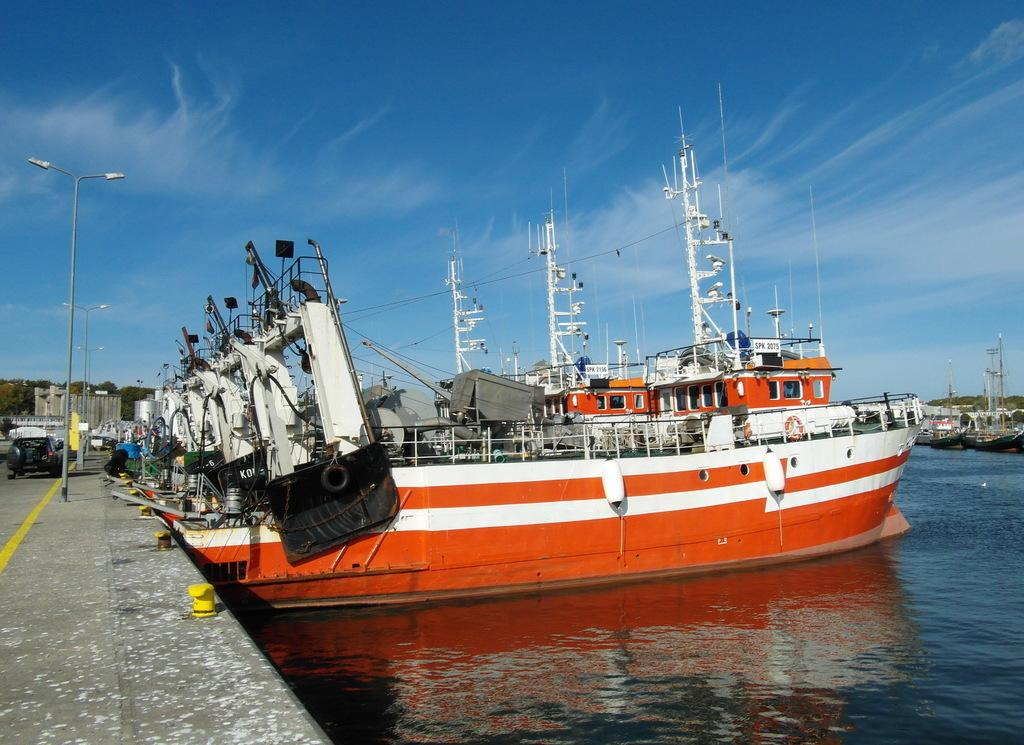What is the main subject of the image? The main subject of the image is ships. What can be seen in the background of the image? There are vehicles and lights visible in the background of the image. What is the terrain like in the image? There is water visible at the bottom of the image. What type of bone can be seen in the image? There is no bone present in the image. How many needles are visible in the image? There are no needles present in the image. 